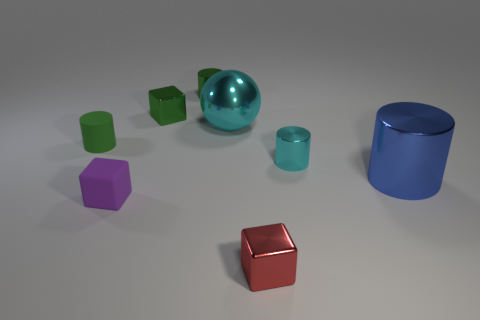Add 2 gray balls. How many objects exist? 10 Subtract all blocks. How many objects are left? 5 Add 6 matte cylinders. How many matte cylinders are left? 7 Add 4 large matte cylinders. How many large matte cylinders exist? 4 Subtract 0 yellow cylinders. How many objects are left? 8 Subtract all small green blocks. Subtract all small green metallic cylinders. How many objects are left? 6 